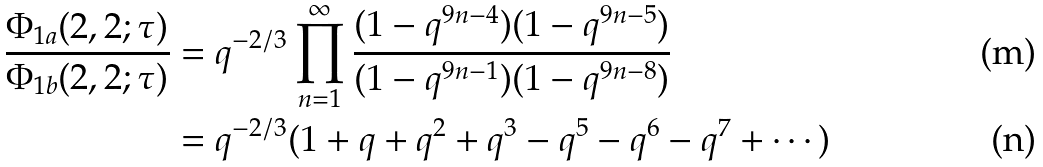Convert formula to latex. <formula><loc_0><loc_0><loc_500><loc_500>\frac { \Phi _ { 1 a } ( 2 , 2 ; \tau ) } { \Phi _ { 1 b } ( 2 , 2 ; \tau ) } & = q ^ { - 2 / 3 } \prod _ { n = 1 } ^ { \infty } \frac { ( 1 - q ^ { 9 n - 4 } ) ( 1 - q ^ { 9 n - 5 } ) } { ( 1 - q ^ { 9 n - 1 } ) ( 1 - q ^ { 9 n - 8 } ) } \\ & = q ^ { - 2 / 3 } ( 1 + q + q ^ { 2 } + q ^ { 3 } - q ^ { 5 } - q ^ { 6 } - q ^ { 7 } + \cdots )</formula> 